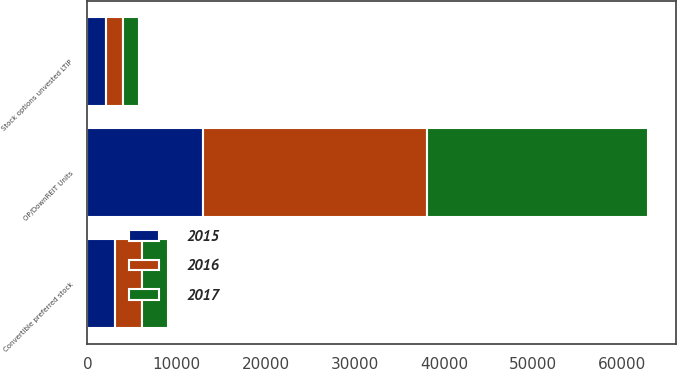Convert chart to OTSL. <chart><loc_0><loc_0><loc_500><loc_500><stacked_bar_chart><ecel><fcel>OP/DownREIT Units<fcel>Convertible preferred stock<fcel>Stock options unvested LTIP<nl><fcel>2017<fcel>24821<fcel>3021<fcel>1806<nl><fcel>2016<fcel>25130<fcel>3028<fcel>1925<nl><fcel>2015<fcel>12947<fcel>3032<fcel>2051<nl></chart> 